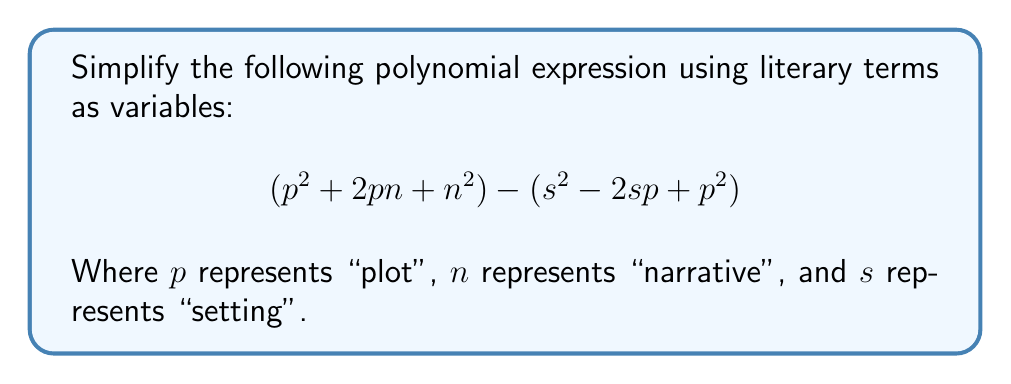Could you help me with this problem? Let's simplify this polynomial expression step by step:

1) First, let's identify the two parts of the expression:
   $$(p^2 + 2pn + n^2)$$ and $$(s^2 - 2sp + p^2)$$

2) We can see that both parts contain $p^2$. When we subtract the second part from the first, these $p^2$ terms will cancel out:
   $$(p^2 + 2pn + n^2) - (s^2 - 2sp + p^2)$$
   $$= (p^2 + 2pn + n^2) - s^2 + 2sp - p^2$$

3) After cancellation of $p^2$, we're left with:
   $$2pn + n^2 - s^2 + 2sp$$

4) Now, let's group the terms with like variables:
   $$n^2 + (2pn + 2sp) - s^2$$

5) The middle term $(2pn + 2sp)$ can be factored:
   $$n^2 + 2p(n + s) - s^2$$

This is our simplified expression. We can interpret this literarily as:
- The square of the narrative ($n^2$)
- Plus twice the plot multiplied by the sum of narrative and setting ($2p(n + s)$)
- Minus the square of the setting ($s^2$)
Answer: $$n^2 + 2p(n + s) - s^2$$ 